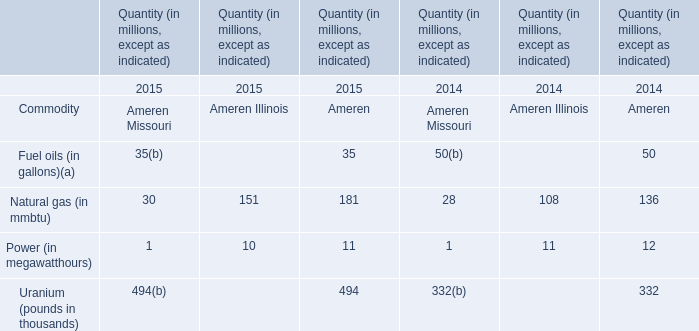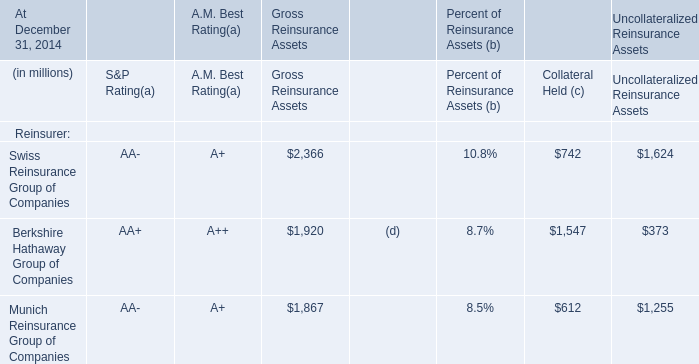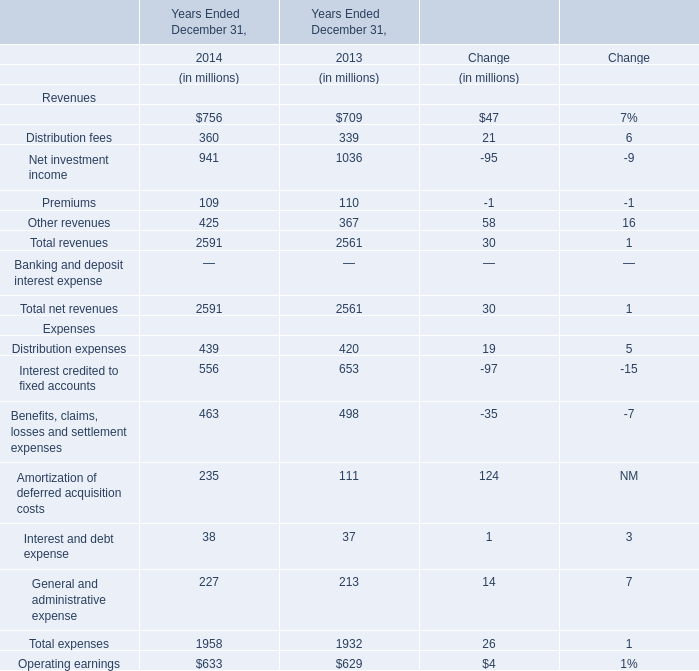In which years is Management and financial advice fees greater than Distribution fees? 
Answer: 2014 2013. 